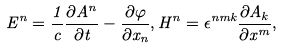<formula> <loc_0><loc_0><loc_500><loc_500>E ^ { n } = \frac { 1 } { c } \frac { \partial A ^ { n } } { \partial t } - \frac { \partial \varphi } { \partial x _ { n } } , H ^ { n } = \epsilon ^ { n m k } \frac { \partial A _ { k } } { \partial x ^ { m } } ,</formula> 